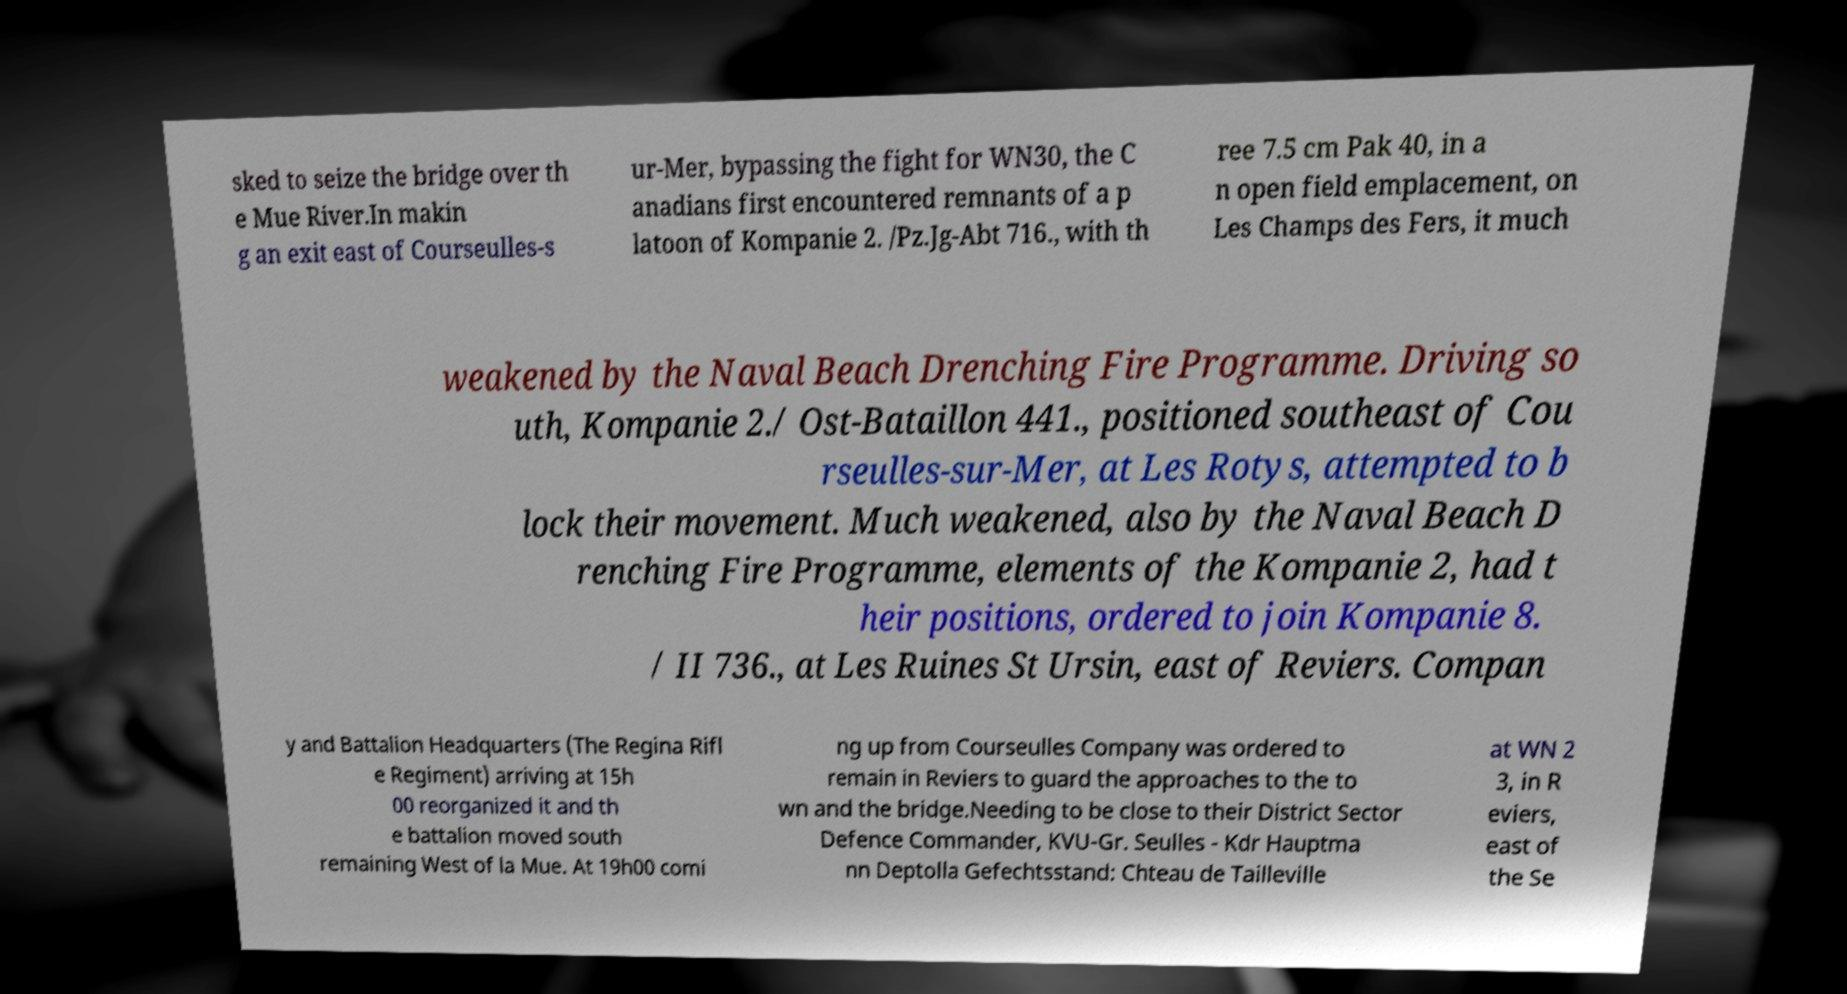Could you extract and type out the text from this image? sked to seize the bridge over th e Mue River.In makin g an exit east of Courseulles-s ur-Mer, bypassing the fight for WN30, the C anadians first encountered remnants of a p latoon of Kompanie 2. /Pz.Jg-Abt 716., with th ree 7.5 cm Pak 40, in a n open field emplacement, on Les Champs des Fers, it much weakened by the Naval Beach Drenching Fire Programme. Driving so uth, Kompanie 2./ Ost-Bataillon 441., positioned southeast of Cou rseulles-sur-Mer, at Les Rotys, attempted to b lock their movement. Much weakened, also by the Naval Beach D renching Fire Programme, elements of the Kompanie 2, had t heir positions, ordered to join Kompanie 8. / II 736., at Les Ruines St Ursin, east of Reviers. Compan y and Battalion Headquarters (The Regina Rifl e Regiment) arriving at 15h 00 reorganized it and th e battalion moved south remaining West of la Mue. At 19h00 comi ng up from Courseulles Company was ordered to remain in Reviers to guard the approaches to the to wn and the bridge.Needing to be close to their District Sector Defence Commander, KVU-Gr. Seulles - Kdr Hauptma nn Deptolla Gefechtsstand: Chteau de Tailleville at WN 2 3, in R eviers, east of the Se 